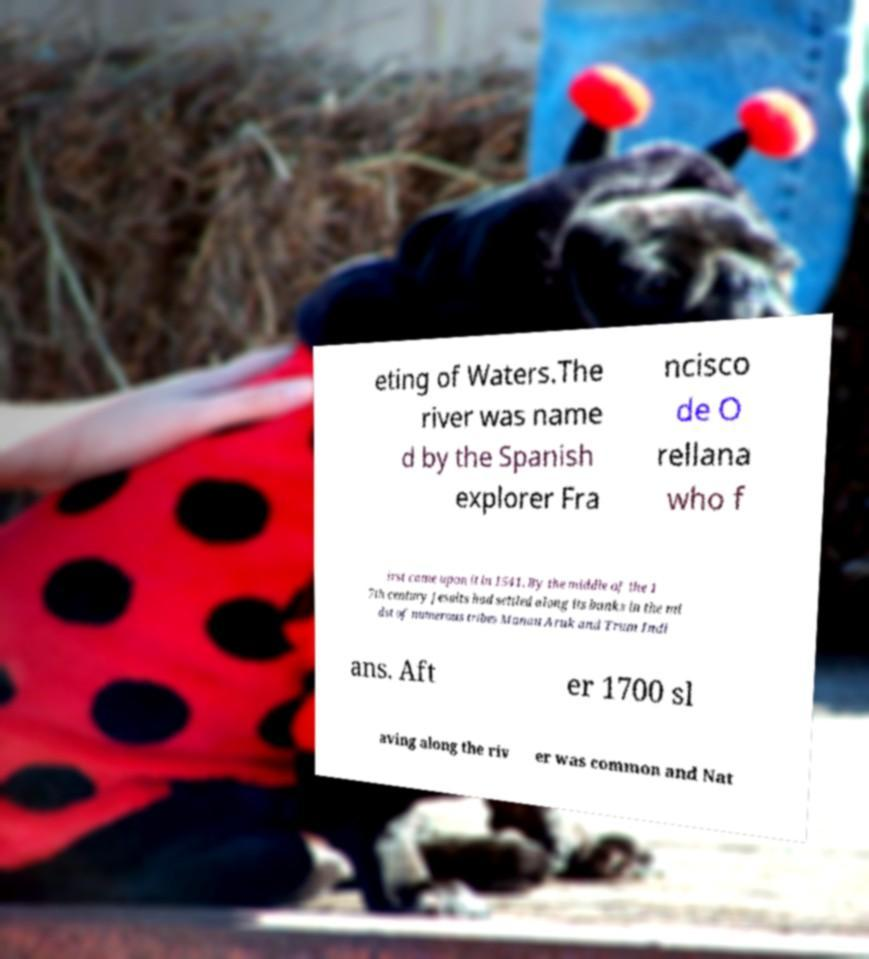Please read and relay the text visible in this image. What does it say? eting of Waters.The river was name d by the Spanish explorer Fra ncisco de O rellana who f irst came upon it in 1541. By the middle of the 1 7th century Jesuits had settled along its banks in the mi dst of numerous tribes Manau Aruk and Trum Indi ans. Aft er 1700 sl aving along the riv er was common and Nat 